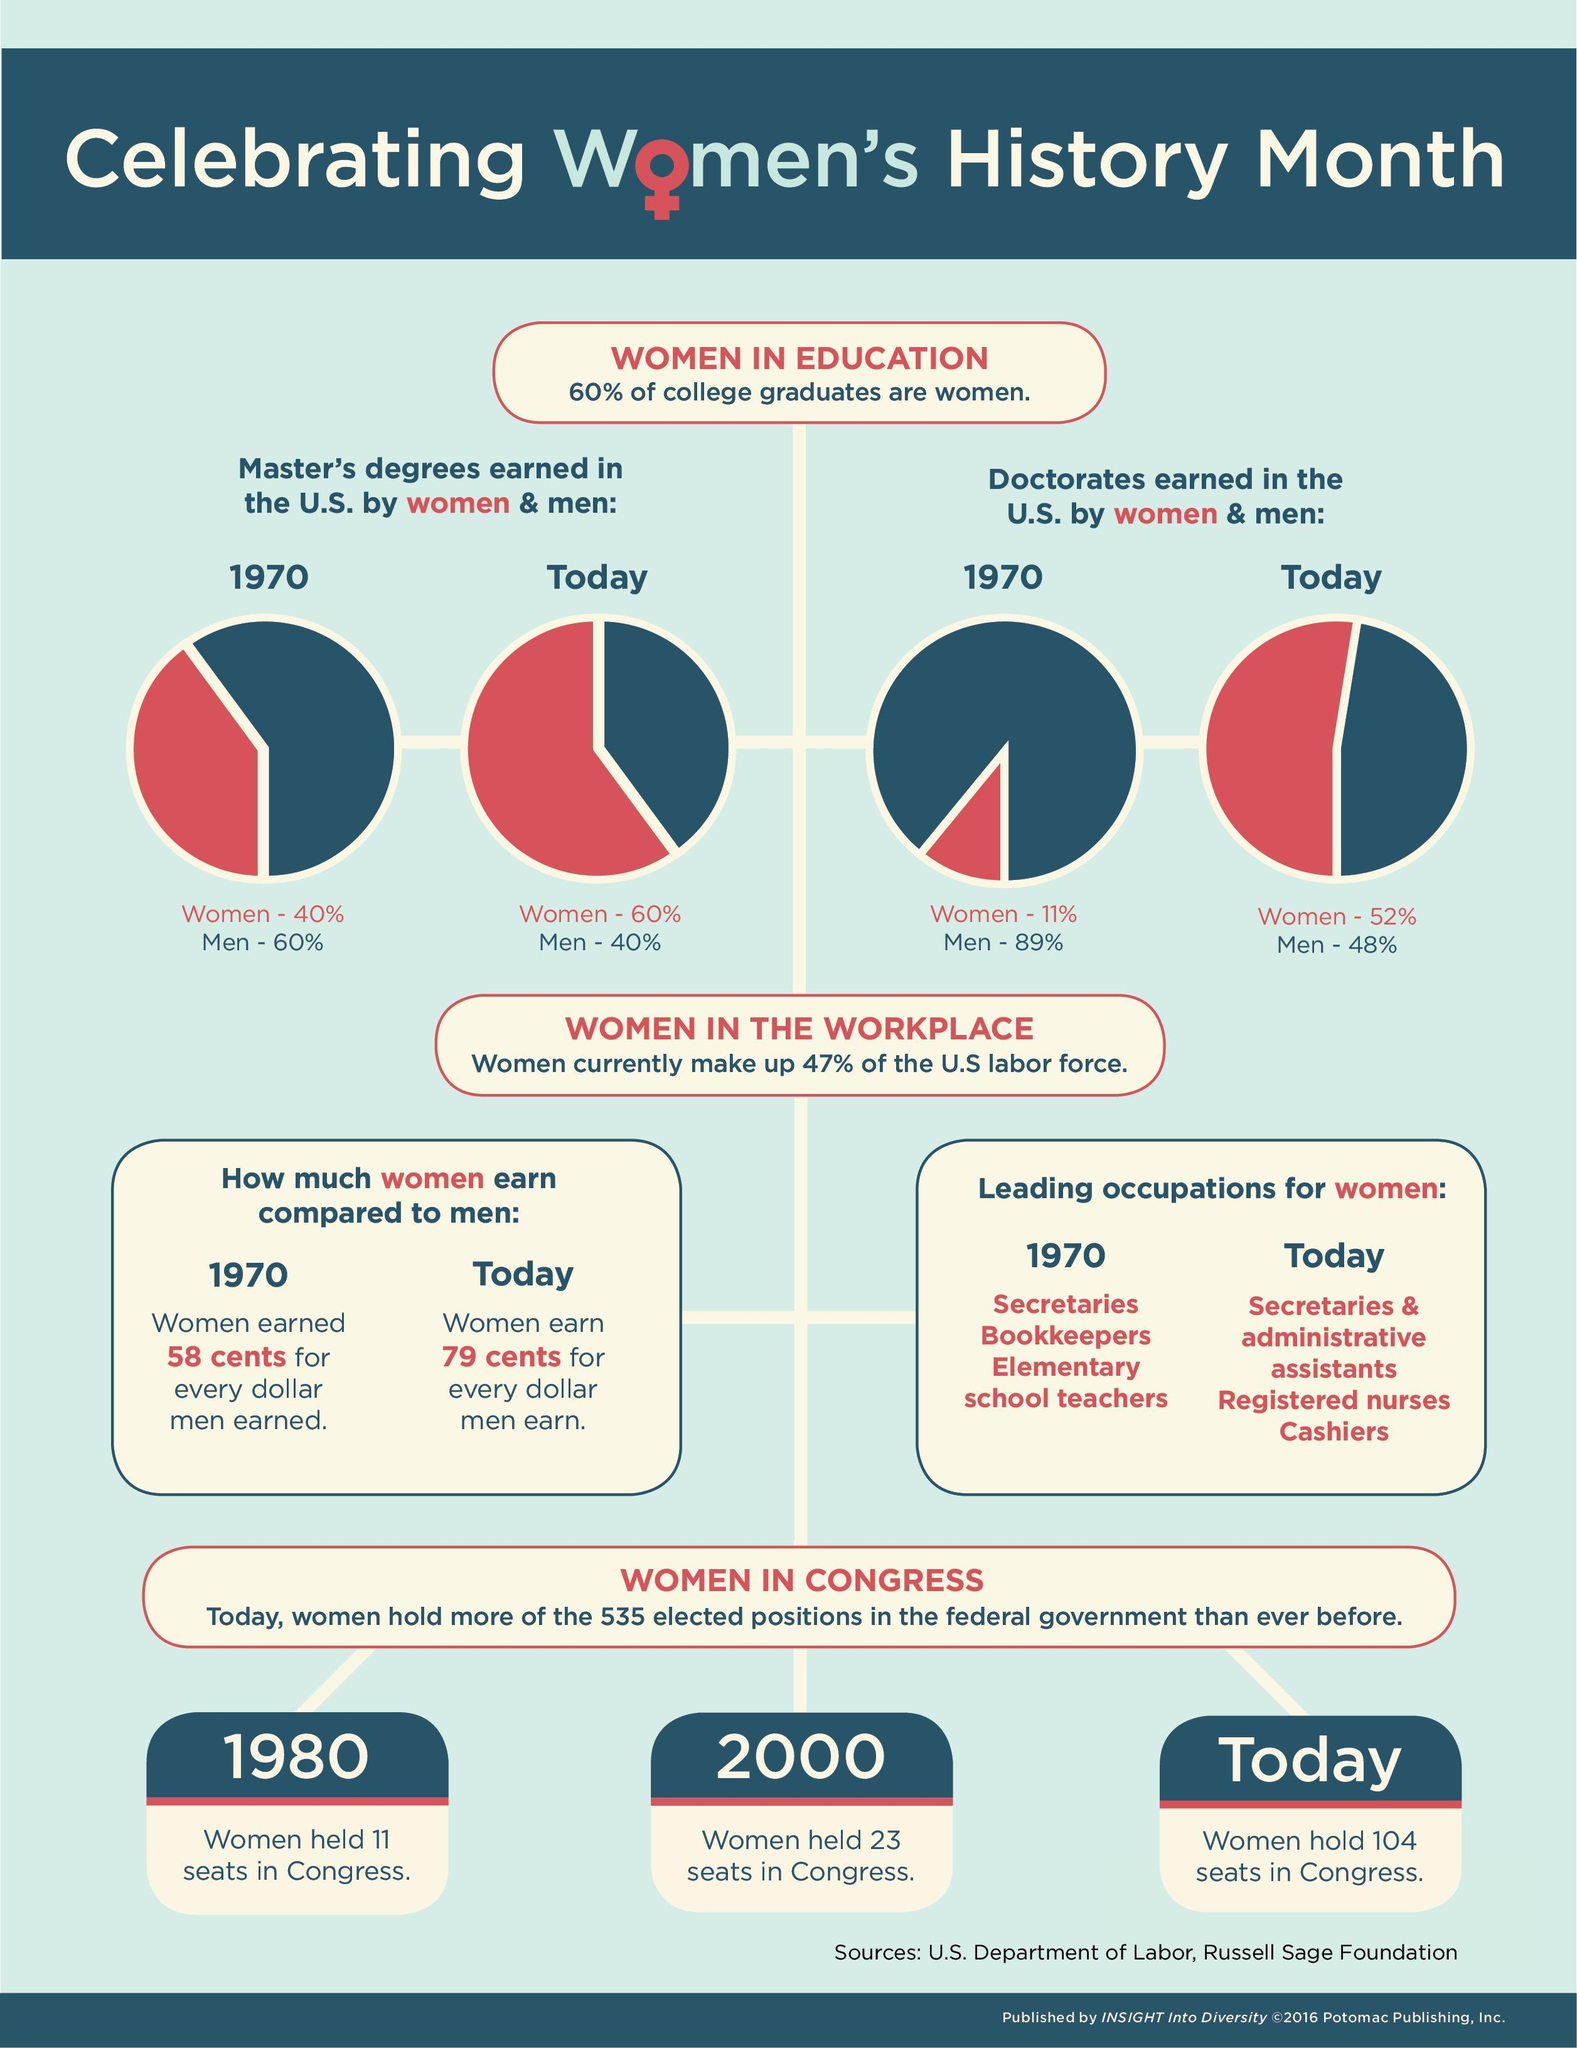By what percent has the percent of men earning doctorates in the US reduced from 1970 till today?
Answer the question with a short phrase. 41% By what percent has the percent of women earning master's degrees in the US increase from 1970 to today? 20% 